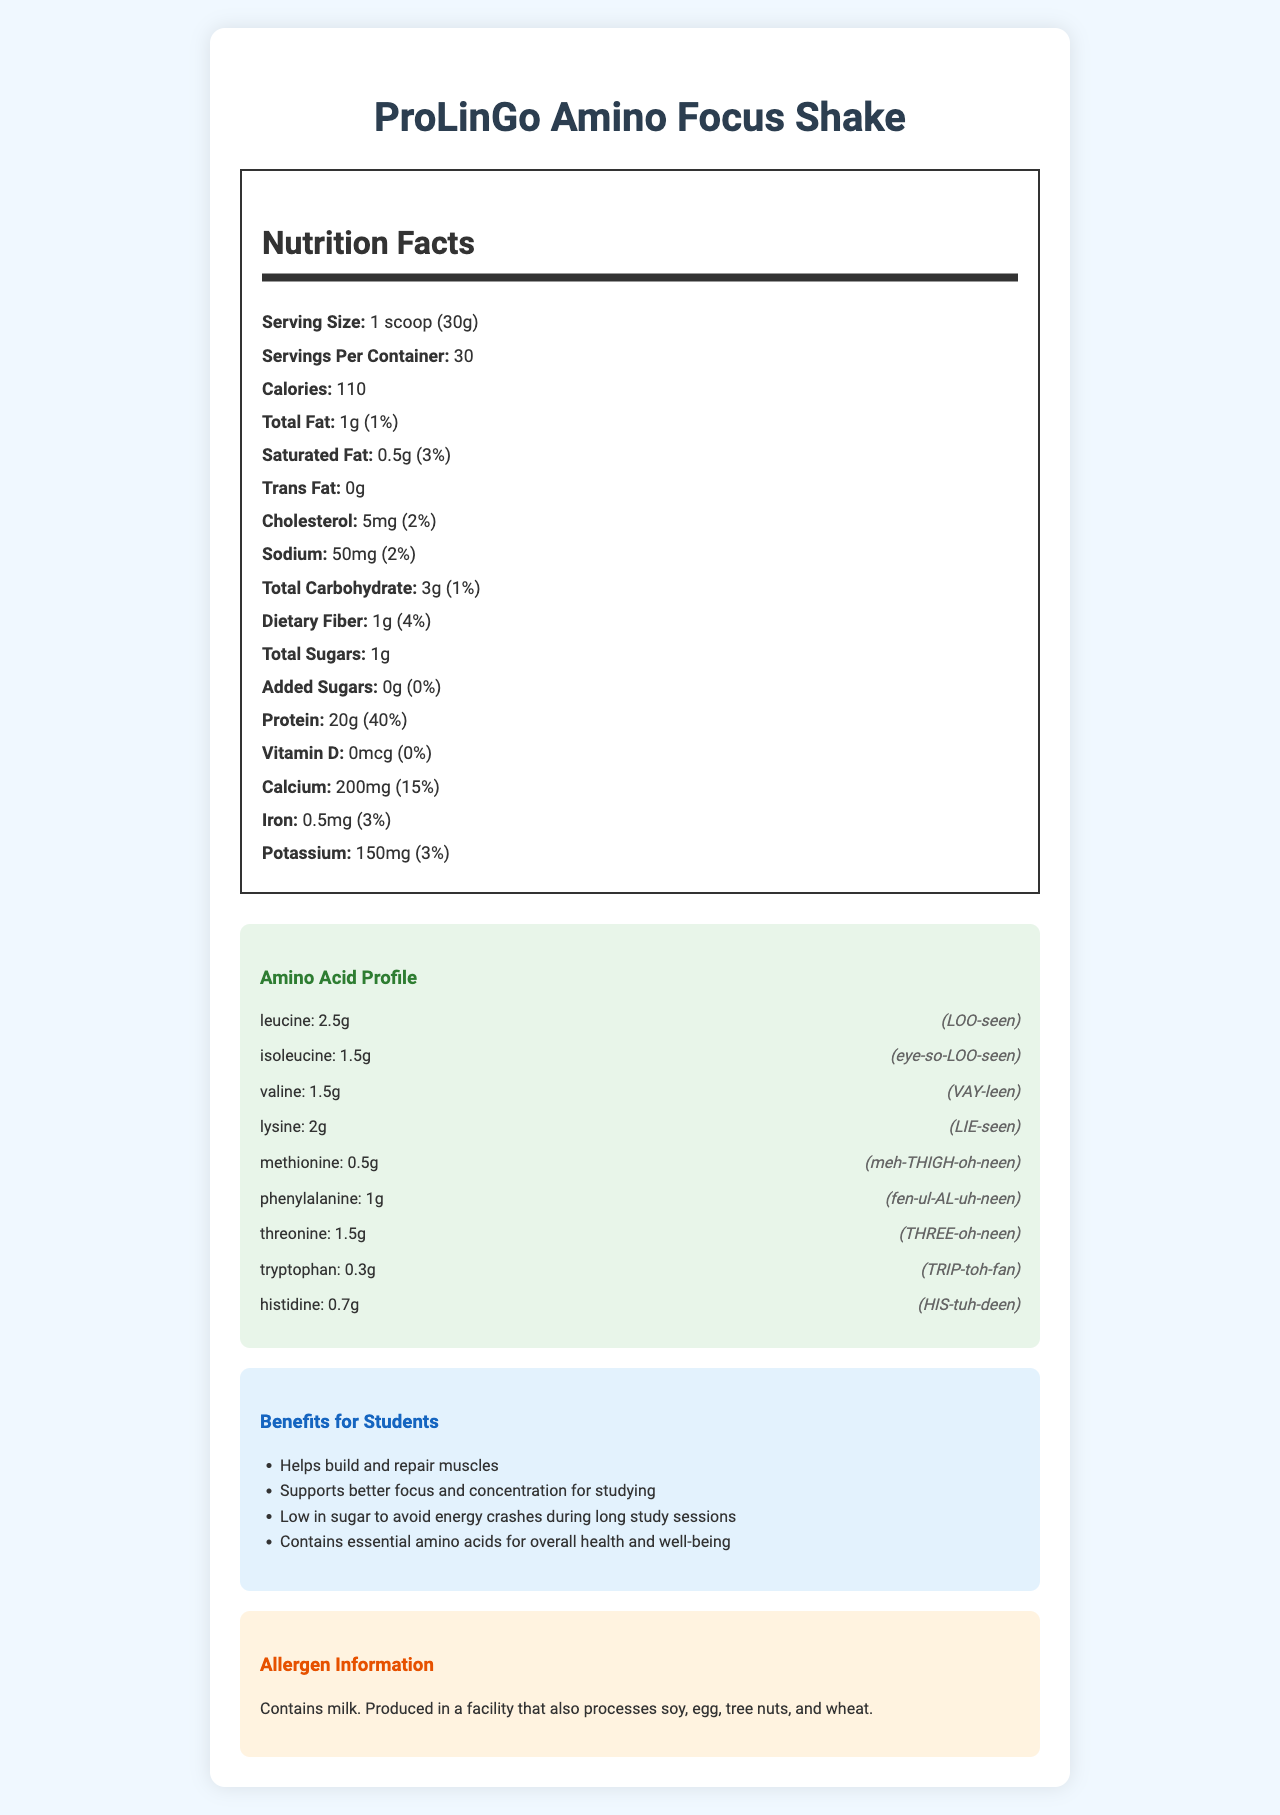what is the serving size of the ProLinGo Amino Focus Shake? The serving size is explicitly stated in the document as "1 scoop (30g)".
Answer: 1 scoop (30g) how many calories are in one serving? The document lists the calories as 110 per serving.
Answer: 110 what amino acid has the highest amount per serving? Leucine has the highest amount per serving at 2.5g as stated in the amino acid profile.
Answer: Leucine what is the percentage daily value of protein in one serving? The protein daily value percentage provided in the document is 40%.
Answer: 40% does the product contain any added sugars? The document states that the amount of added sugars is 0g, which corresponds to 0% of the daily value.
Answer: No which ingredient is used as a sweetener? Among the ingredients listed, stevia leaf extract is used as a sweetener.
Answer: Stevia leaf extract how much calcium is present in one serving of the shake? The document lists calcium at 200mg per serving.
Answer: 200mg how many grams of saturated fat are there in one serving? The amount of saturated fat per serving is specified as 0.5g.
Answer: 0.5g which of the following best describes an amino acid present in the highest amount? A. Lysine B. Valine C. Leucine Leucine is present in the highest amount among the listed amino acids, with 2.5g per serving.
Answer: C. Leucine what is the main allergen listed for ProLinGo Amino Focus Shake? A. Soy B. Milk C. Wheat D. Egg The allergen information states that the product contains milk.
Answer: B. Milk is the ProLinGo Amino Focus Shake high in dietary fiber? The document shows that the dietary fiber content is 1g per serving, which corresponds to 4% of the daily value, not considered high.
Answer: No summarize the main idea of the document. The document is essentially a comprehensive overview of the nutritional content and benefits of the ProLinGo Amino Focus Shake, detailing macro and micronutrients, the amino acid profile, and relevant student-friendly features.
Answer: The document is a detailed nutrition facts label for ProLinGo Amino Focus Shake, which includes information on serving size, calorie content, fat, cholesterol, sodium, carbohydrates, dietary fiber, sugars, protein, vitamins, minerals, and a breakdown of the amino acid profile. The label also features a pronunciation guide for amino acids and lists simplified benefits for students. Additionally, it includes allergen information, indicating the product contains milk. does the shake help with energy crashes during long study sessions? One of the benefits listed in the document was "Low in sugar to avoid energy crashes during long study sessions."
Answer: Yes is the vitamin D content high in this product? Vitamin D in this product is listed as 0mcg, which corresponds to 0% of the daily value, implying no vitamin D content.
Answer: No can you determine if the product is gluten-free? The document mentions that the product is produced in a facility that processes wheat, but it does not specify if the product itself is gluten-free.
Answer: Not enough information 